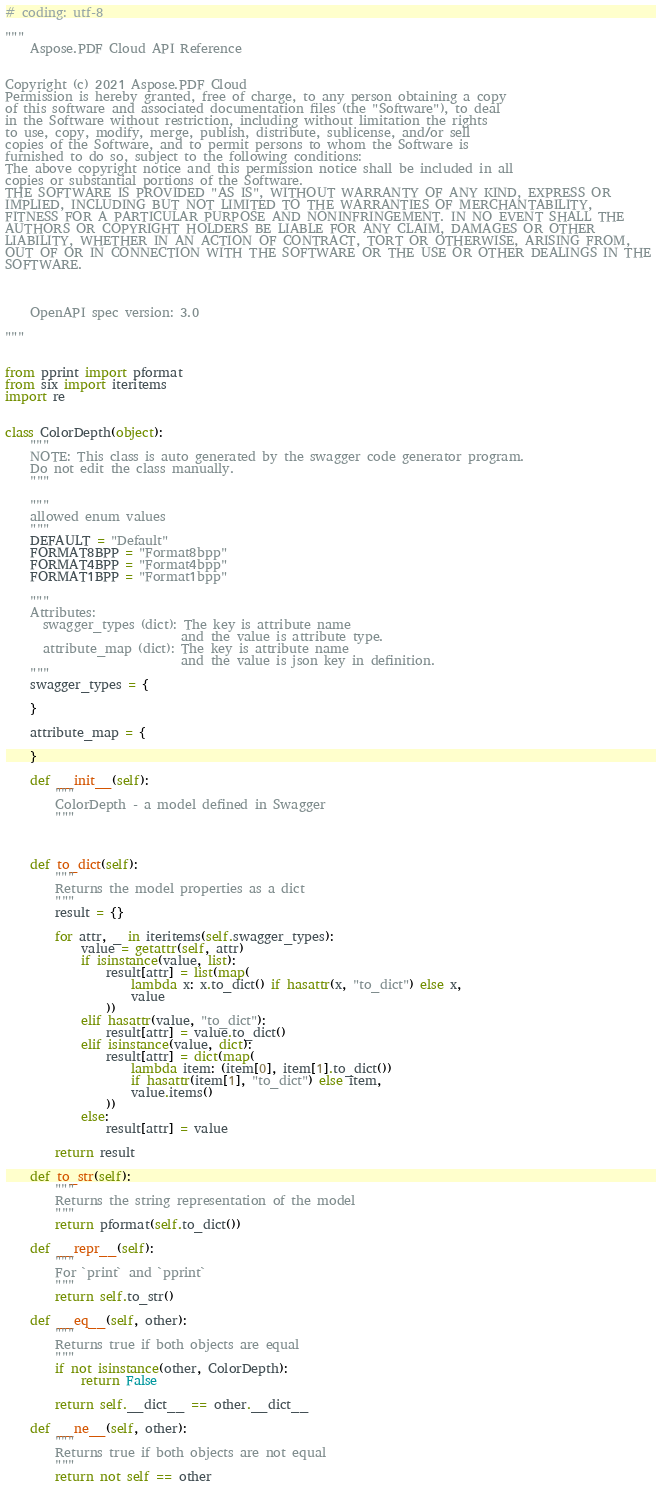Convert code to text. <code><loc_0><loc_0><loc_500><loc_500><_Python_># coding: utf-8

"""
    Aspose.PDF Cloud API Reference


Copyright (c) 2021 Aspose.PDF Cloud
Permission is hereby granted, free of charge, to any person obtaining a copy
of this software and associated documentation files (the "Software"), to deal
in the Software without restriction, including without limitation the rights
to use, copy, modify, merge, publish, distribute, sublicense, and/or sell
copies of the Software, and to permit persons to whom the Software is
furnished to do so, subject to the following conditions:
The above copyright notice and this permission notice shall be included in all
copies or substantial portions of the Software.
THE SOFTWARE IS PROVIDED "AS IS", WITHOUT WARRANTY OF ANY KIND, EXPRESS OR
IMPLIED, INCLUDING BUT NOT LIMITED TO THE WARRANTIES OF MERCHANTABILITY,
FITNESS FOR A PARTICULAR PURPOSE AND NONINFRINGEMENT. IN NO EVENT SHALL THE
AUTHORS OR COPYRIGHT HOLDERS BE LIABLE FOR ANY CLAIM, DAMAGES OR OTHER
LIABILITY, WHETHER IN AN ACTION OF CONTRACT, TORT OR OTHERWISE, ARISING FROM,
OUT OF OR IN CONNECTION WITH THE SOFTWARE OR THE USE OR OTHER DEALINGS IN THE
SOFTWARE.



    OpenAPI spec version: 3.0
    
"""


from pprint import pformat
from six import iteritems
import re


class ColorDepth(object):
    """
    NOTE: This class is auto generated by the swagger code generator program.
    Do not edit the class manually.
    """

    """
    allowed enum values
    """
    DEFAULT = "Default"
    FORMAT8BPP = "Format8bpp"
    FORMAT4BPP = "Format4bpp"
    FORMAT1BPP = "Format1bpp"

    """
    Attributes:
      swagger_types (dict): The key is attribute name
                            and the value is attribute type.
      attribute_map (dict): The key is attribute name
                            and the value is json key in definition.
    """
    swagger_types = {
        
    }

    attribute_map = {
        
    }

    def __init__(self):
        """
        ColorDepth - a model defined in Swagger
        """



    def to_dict(self):
        """
        Returns the model properties as a dict
        """
        result = {}

        for attr, _ in iteritems(self.swagger_types):
            value = getattr(self, attr)
            if isinstance(value, list):
                result[attr] = list(map(
                    lambda x: x.to_dict() if hasattr(x, "to_dict") else x,
                    value
                ))
            elif hasattr(value, "to_dict"):
                result[attr] = value.to_dict()
            elif isinstance(value, dict):
                result[attr] = dict(map(
                    lambda item: (item[0], item[1].to_dict())
                    if hasattr(item[1], "to_dict") else item,
                    value.items()
                ))
            else:
                result[attr] = value

        return result

    def to_str(self):
        """
        Returns the string representation of the model
        """
        return pformat(self.to_dict())

    def __repr__(self):
        """
        For `print` and `pprint`
        """
        return self.to_str()

    def __eq__(self, other):
        """
        Returns true if both objects are equal
        """
        if not isinstance(other, ColorDepth):
            return False

        return self.__dict__ == other.__dict__

    def __ne__(self, other):
        """
        Returns true if both objects are not equal
        """
        return not self == other
</code> 